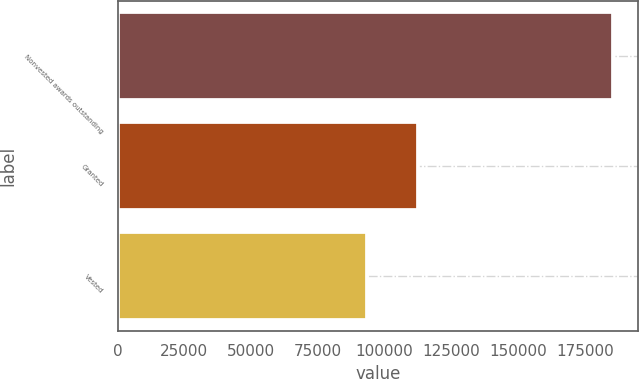<chart> <loc_0><loc_0><loc_500><loc_500><bar_chart><fcel>Nonvested awards outstanding<fcel>Granted<fcel>Vested<nl><fcel>185700<fcel>112500<fcel>93500<nl></chart> 